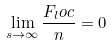Convert formula to latex. <formula><loc_0><loc_0><loc_500><loc_500>\lim _ { s \rightarrow \infty } \frac { F _ { l } o c } { n } = 0</formula> 